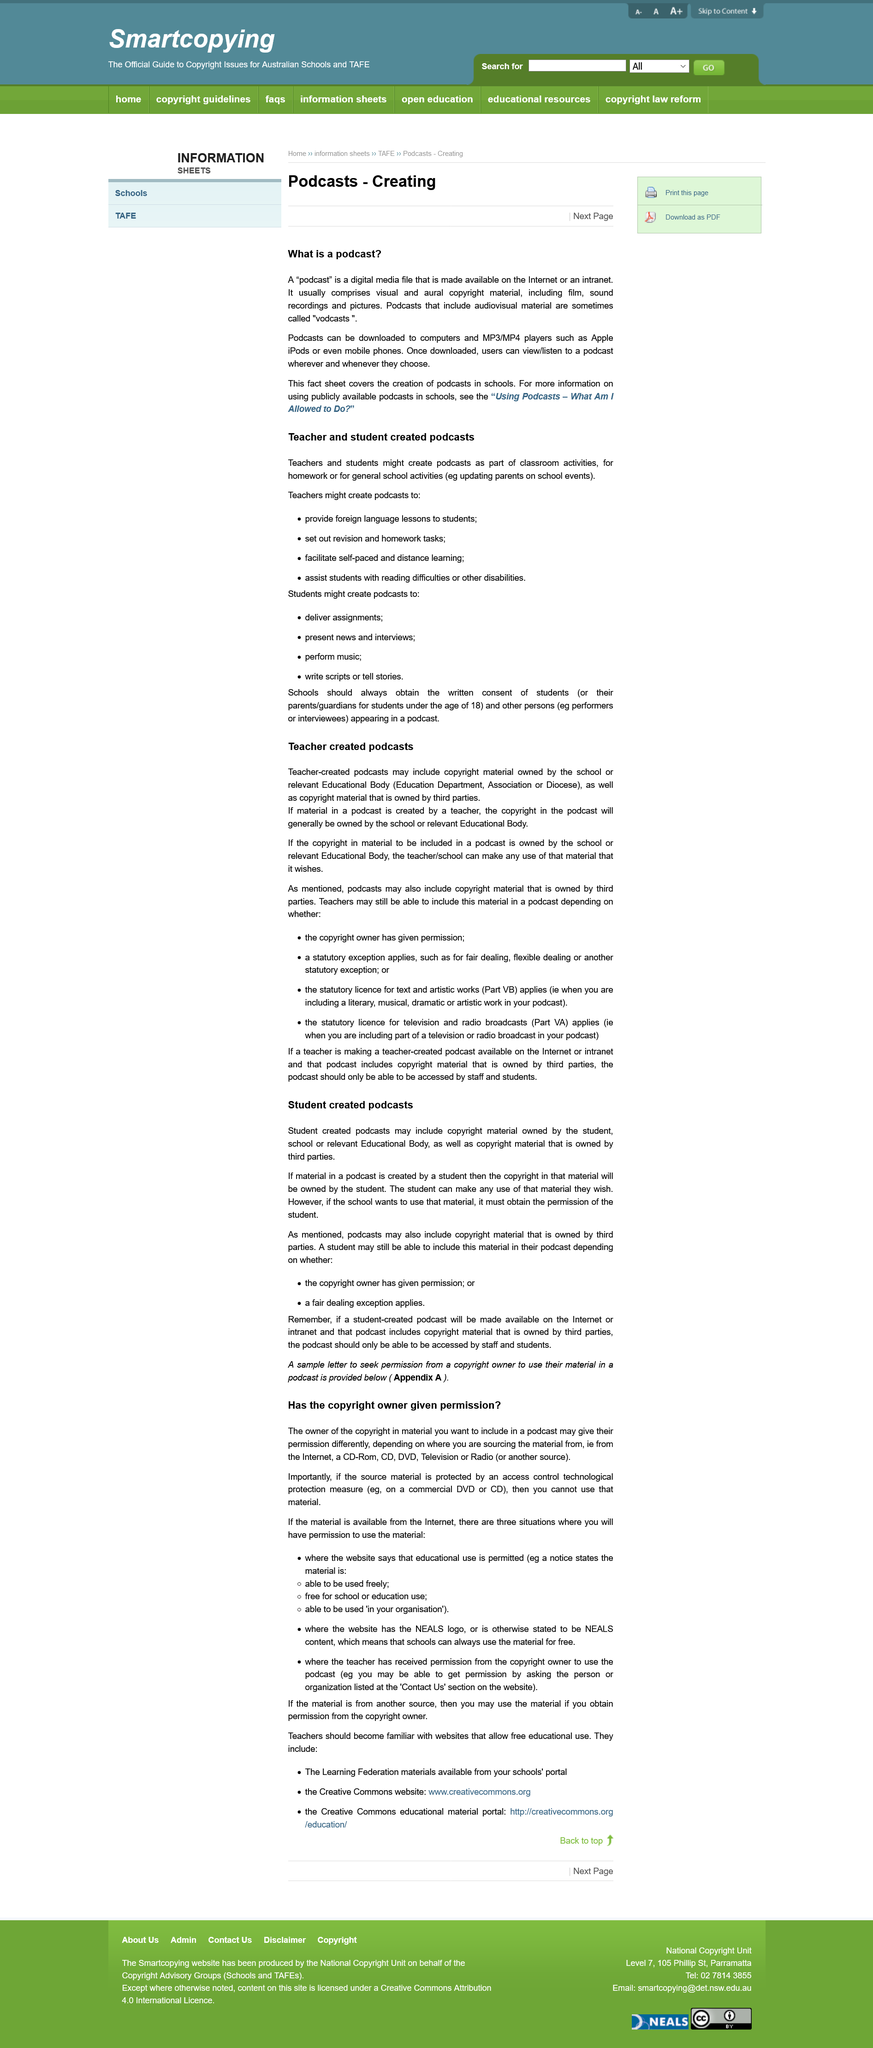Specify some key components in this picture. In the context of creating podcasts, teachers and students engage in classroom/general school activities. Teachers have the ability to create podcasts about various topics, such as providing foreign language lessons to students, setting out revision and homework tasks, facilitating self-paced and distance learning, and assisting students with reading difficulties or other disabilities. It is not permissible to use material from the internet in a podcast under any circumstances, except in three specific situations. The copyright for material created by a student in a podcast would belong to the student, as per copyright law. A student can create podcasts on various topics such as delivering assignments, presenting news and interviews, performing music, and writing scripts or telling stories. 